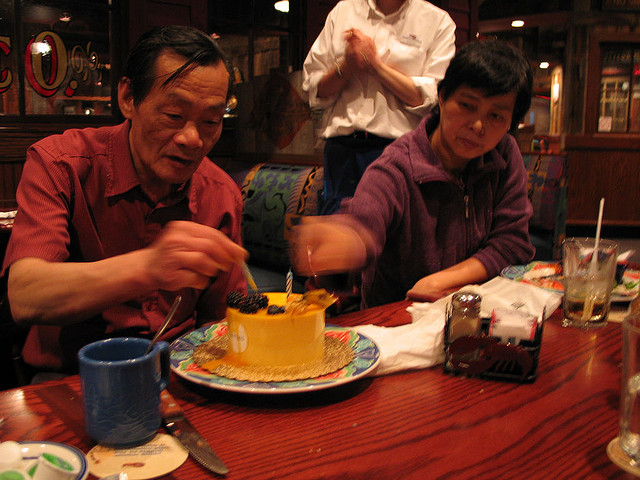Identify the text displayed in this image. C 0 